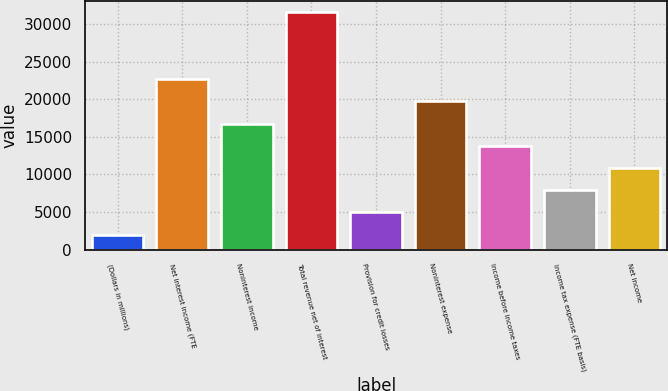<chart> <loc_0><loc_0><loc_500><loc_500><bar_chart><fcel>(Dollars in millions)<fcel>Net interest income (FTE<fcel>Noninterest income<fcel>Total revenue net of interest<fcel>Provision for credit losses<fcel>Noninterest expense<fcel>Income before income taxes<fcel>Income tax expense (FTE basis)<fcel>Net income<nl><fcel>2015<fcel>22672<fcel>16770<fcel>31525<fcel>4966<fcel>19721<fcel>13819<fcel>7917<fcel>10868<nl></chart> 